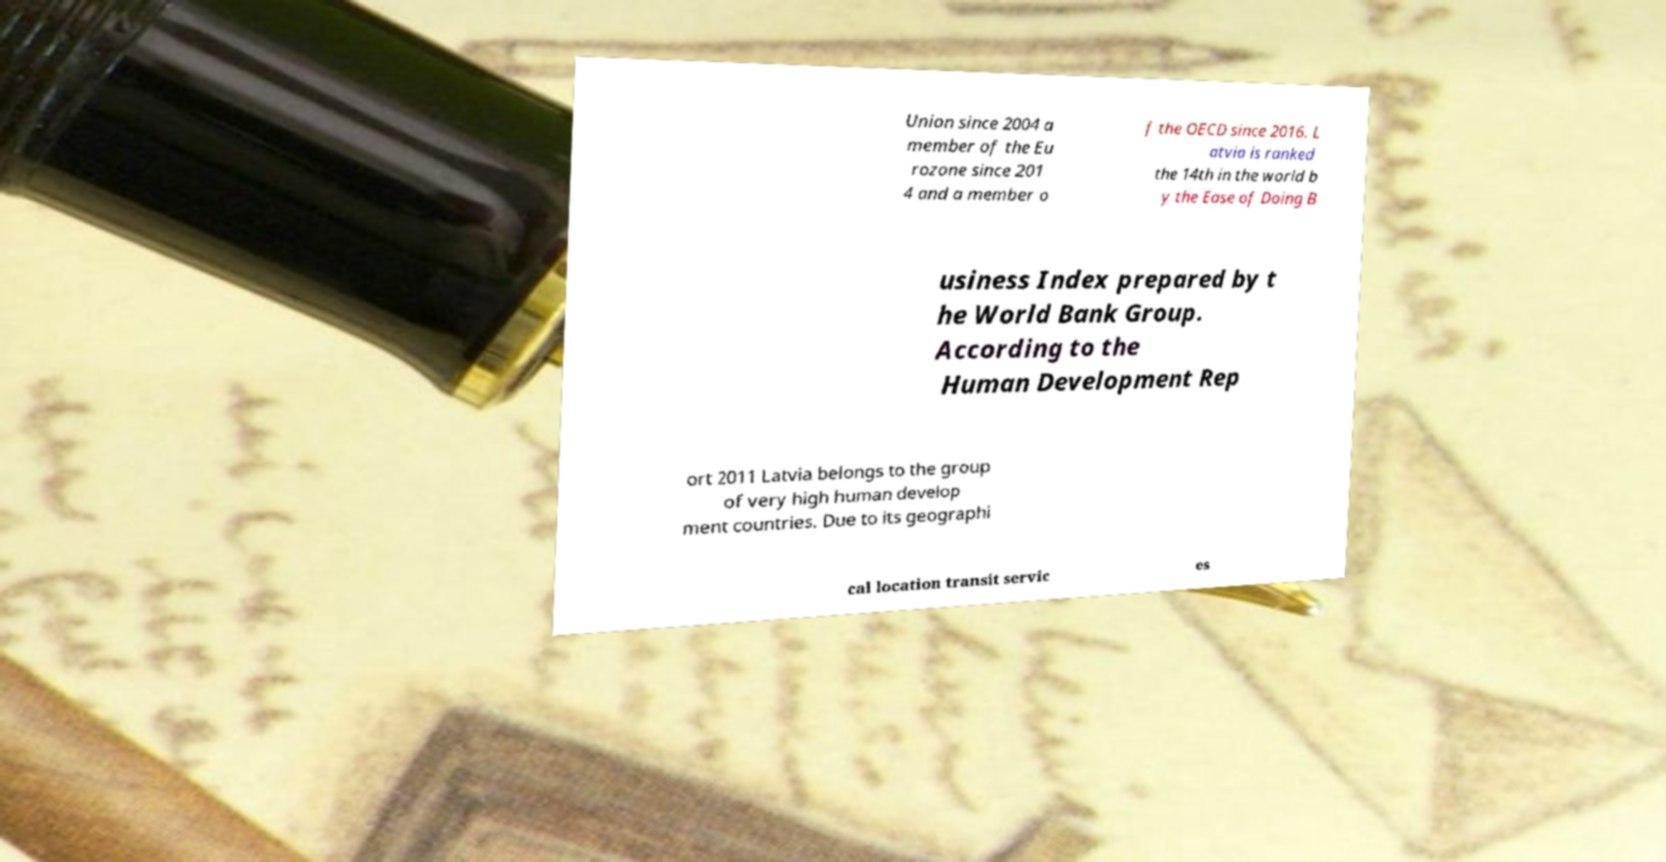For documentation purposes, I need the text within this image transcribed. Could you provide that? Union since 2004 a member of the Eu rozone since 201 4 and a member o f the OECD since 2016. L atvia is ranked the 14th in the world b y the Ease of Doing B usiness Index prepared by t he World Bank Group. According to the Human Development Rep ort 2011 Latvia belongs to the group of very high human develop ment countries. Due to its geographi cal location transit servic es 